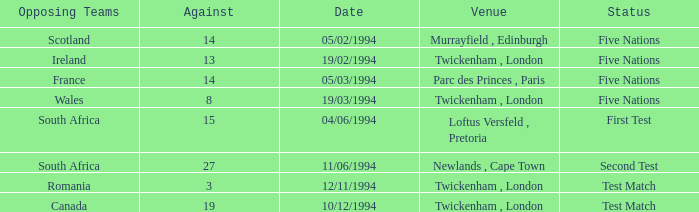How many cases have a "first test" status against them? 1.0. 